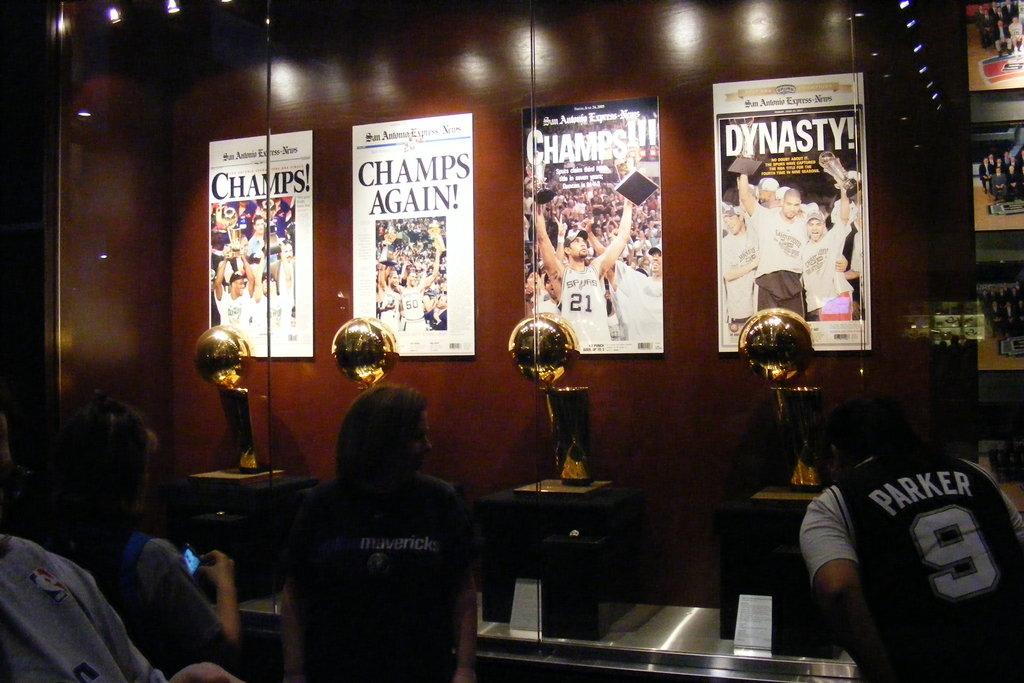What do the posters have in common? how many times did they win?
Your response must be concise. 4. What is the headline on the far left?
Ensure brevity in your answer.  Champs!. 